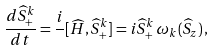<formula> <loc_0><loc_0><loc_500><loc_500>\frac { d \widehat { S } _ { + } ^ { k } } { d t } = \frac { i } { } [ \widehat { H } , \widehat { S } ^ { k } _ { + } ] = i \widehat { S } _ { + } ^ { k } \, \omega _ { k } ( \widehat { S } _ { z } ) \, ,</formula> 